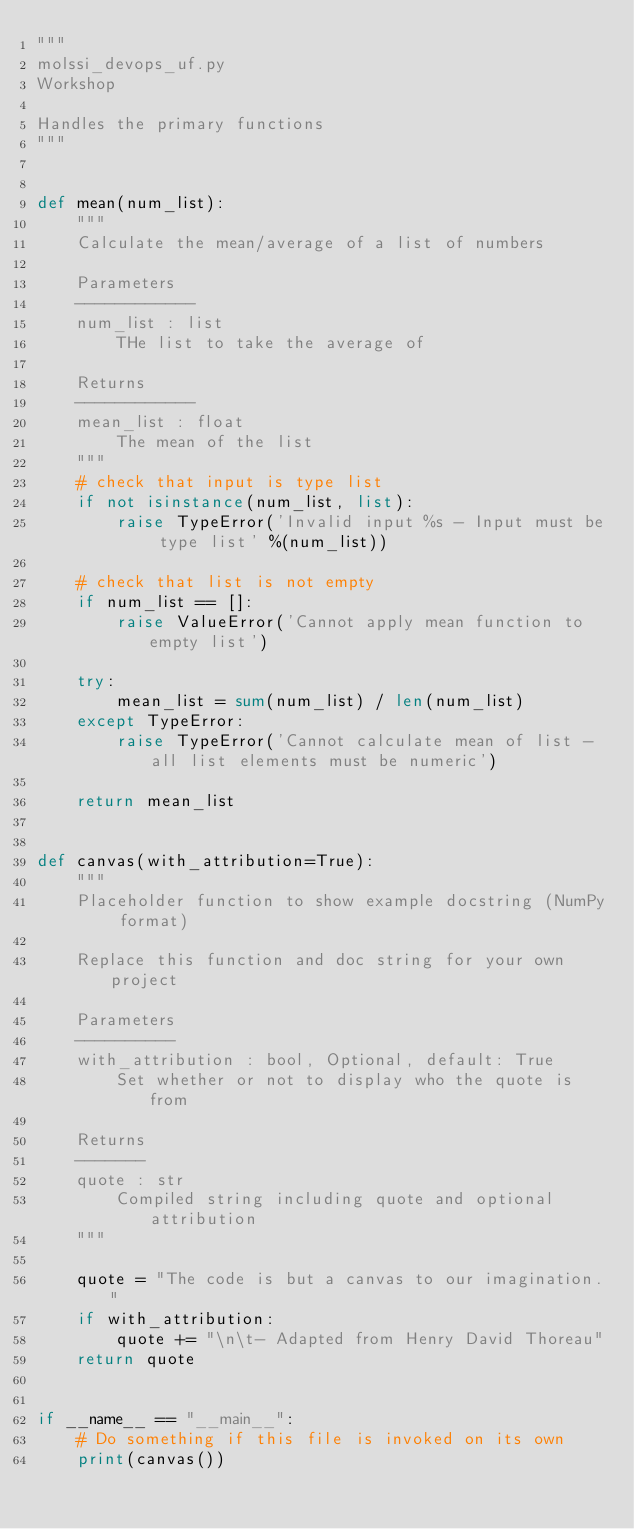Convert code to text. <code><loc_0><loc_0><loc_500><loc_500><_Python_>"""
molssi_devops_uf.py
Workshop

Handles the primary functions
"""


def mean(num_list):
    """
    Calculate the mean/average of a list of numbers

    Parameters
    ------------
    num_list : list
        THe list to take the average of 

    Returns
    ------------
    mean_list : float
        The mean of the list
    """
    # check that input is type list
    if not isinstance(num_list, list):
        raise TypeError('Invalid input %s - Input must be type list' %(num_list))

    # check that list is not empty
    if num_list == []:
        raise ValueError('Cannot apply mean function to empty list')
    
    try:
        mean_list = sum(num_list) / len(num_list)
    except TypeError:
        raise TypeError('Cannot calculate mean of list - all list elements must be numeric')
        
    return mean_list


def canvas(with_attribution=True):
    """
    Placeholder function to show example docstring (NumPy format)

    Replace this function and doc string for your own project

    Parameters
    ----------
    with_attribution : bool, Optional, default: True
        Set whether or not to display who the quote is from

    Returns
    -------
    quote : str
        Compiled string including quote and optional attribution
    """

    quote = "The code is but a canvas to our imagination."
    if with_attribution:
        quote += "\n\t- Adapted from Henry David Thoreau"
    return quote


if __name__ == "__main__":
    # Do something if this file is invoked on its own
    print(canvas())
</code> 